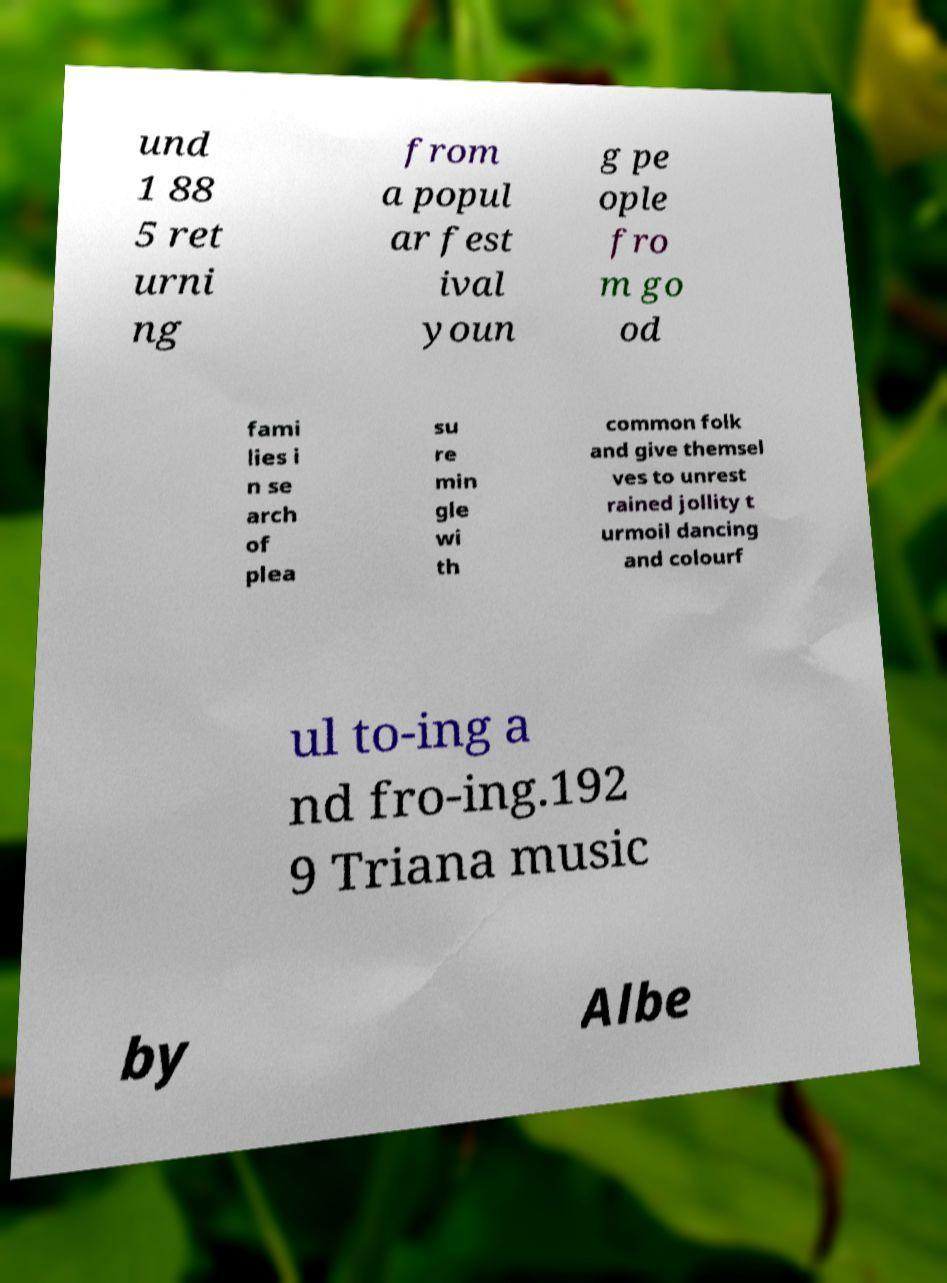I need the written content from this picture converted into text. Can you do that? und 1 88 5 ret urni ng from a popul ar fest ival youn g pe ople fro m go od fami lies i n se arch of plea su re min gle wi th common folk and give themsel ves to unrest rained jollity t urmoil dancing and colourf ul to-ing a nd fro-ing.192 9 Triana music by Albe 